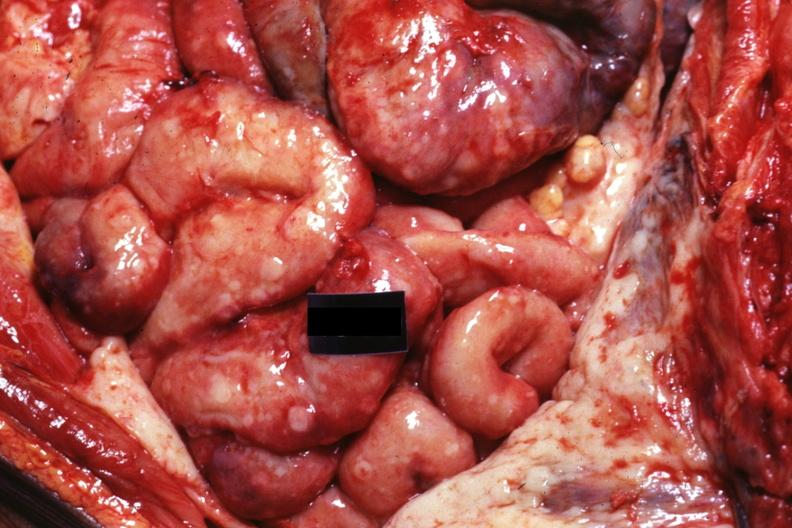s abdomen present?
Answer the question using a single word or phrase. Yes 